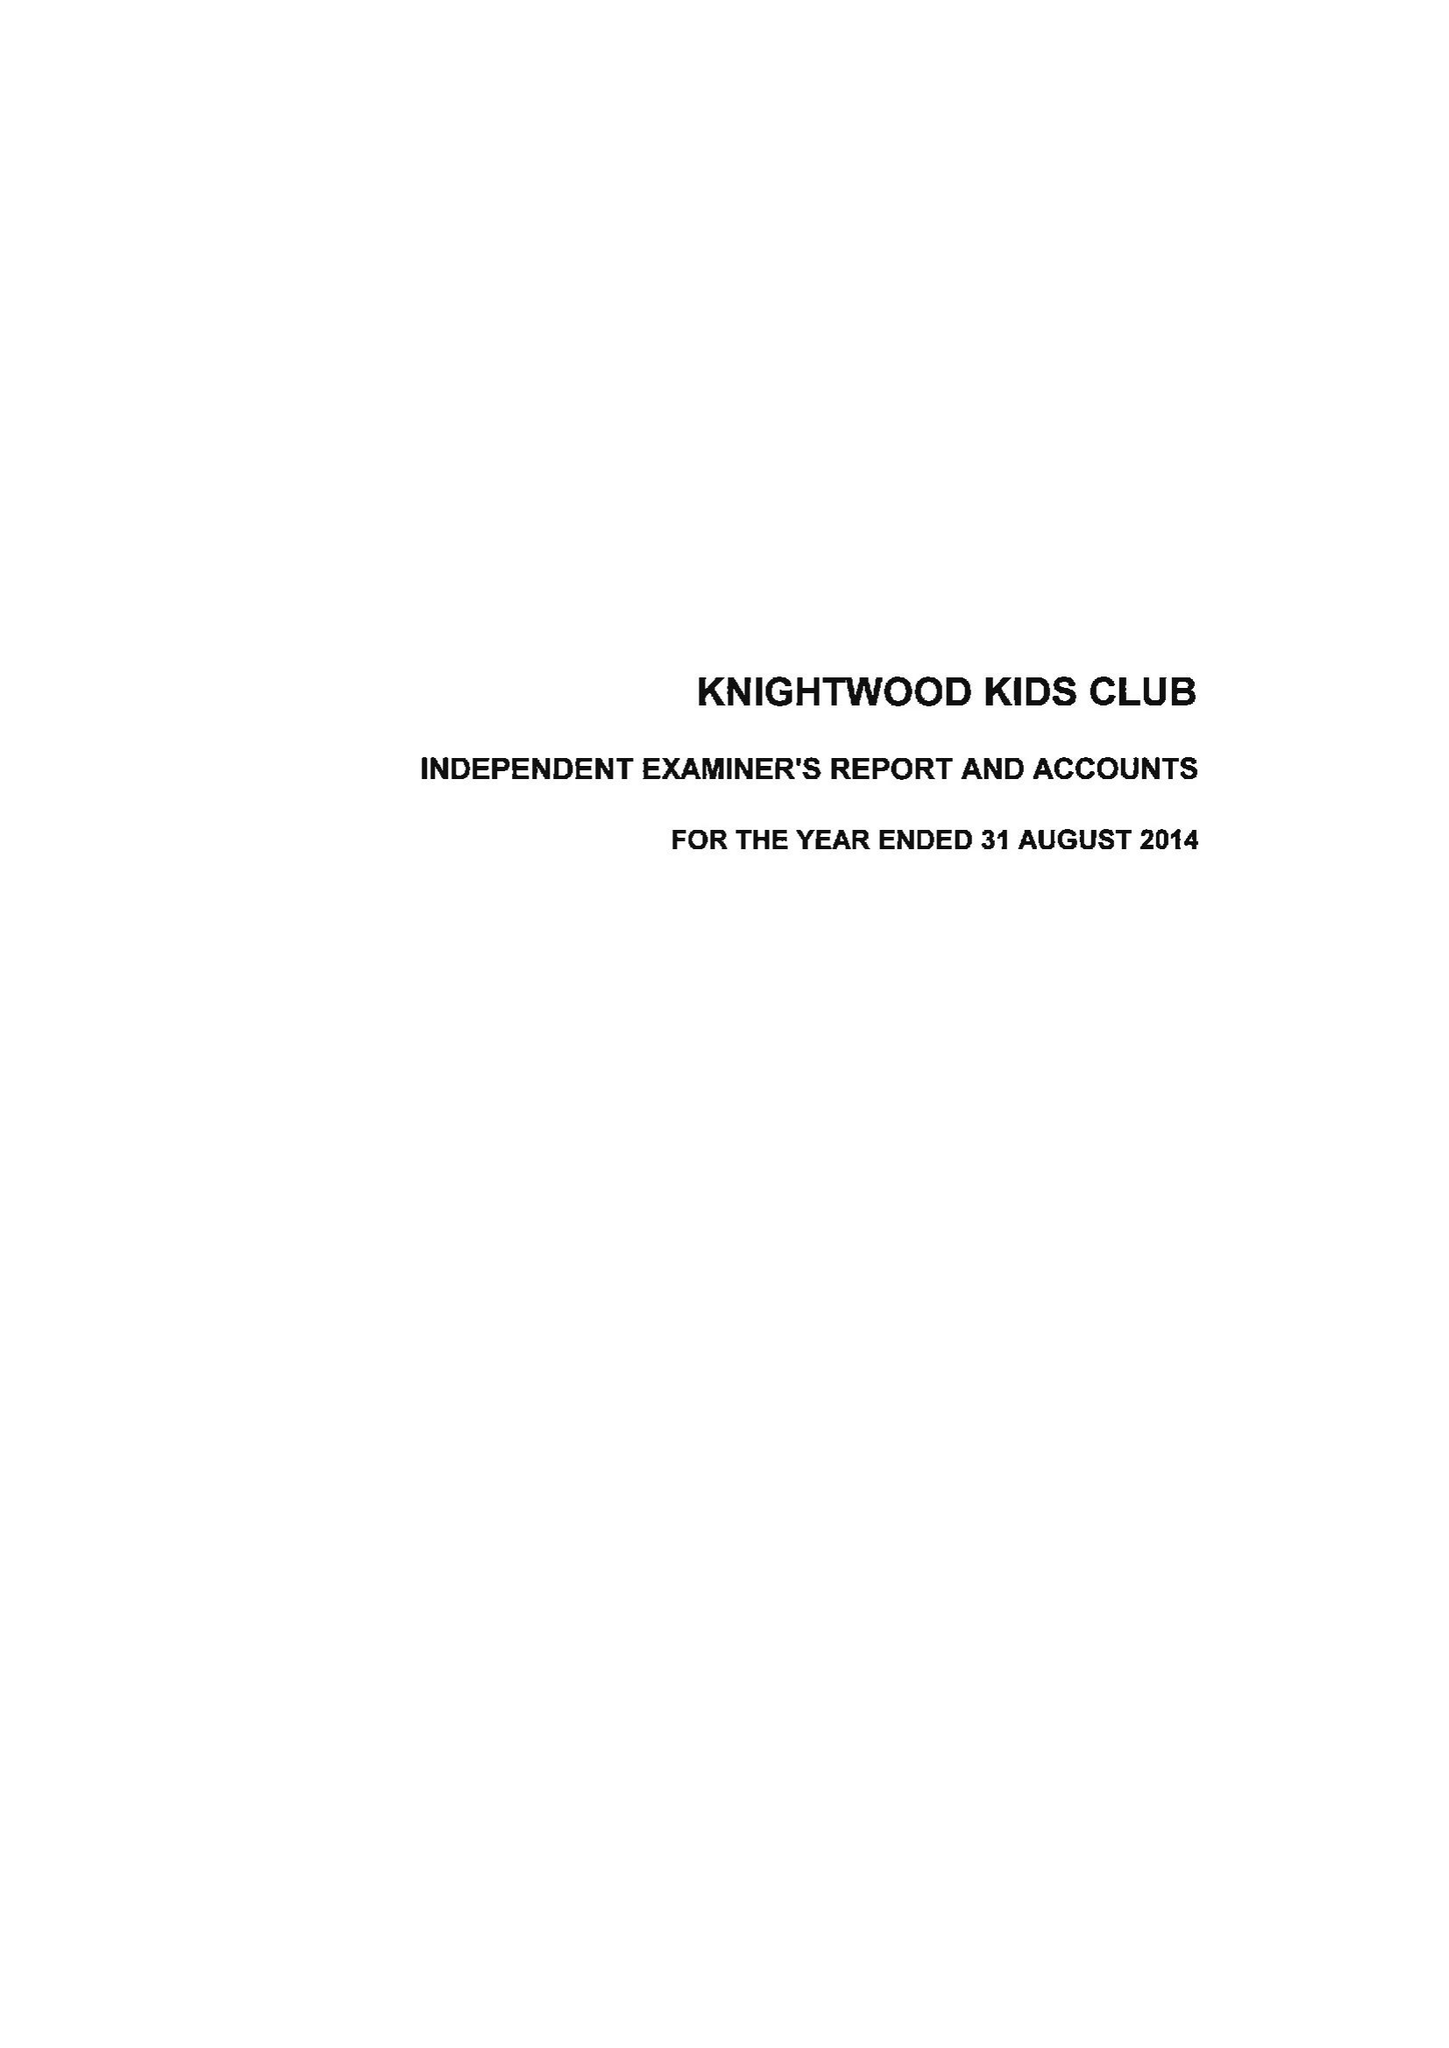What is the value for the address__postcode?
Answer the question using a single word or phrase. SO15 0NX 